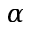Convert formula to latex. <formula><loc_0><loc_0><loc_500><loc_500>\alpha</formula> 